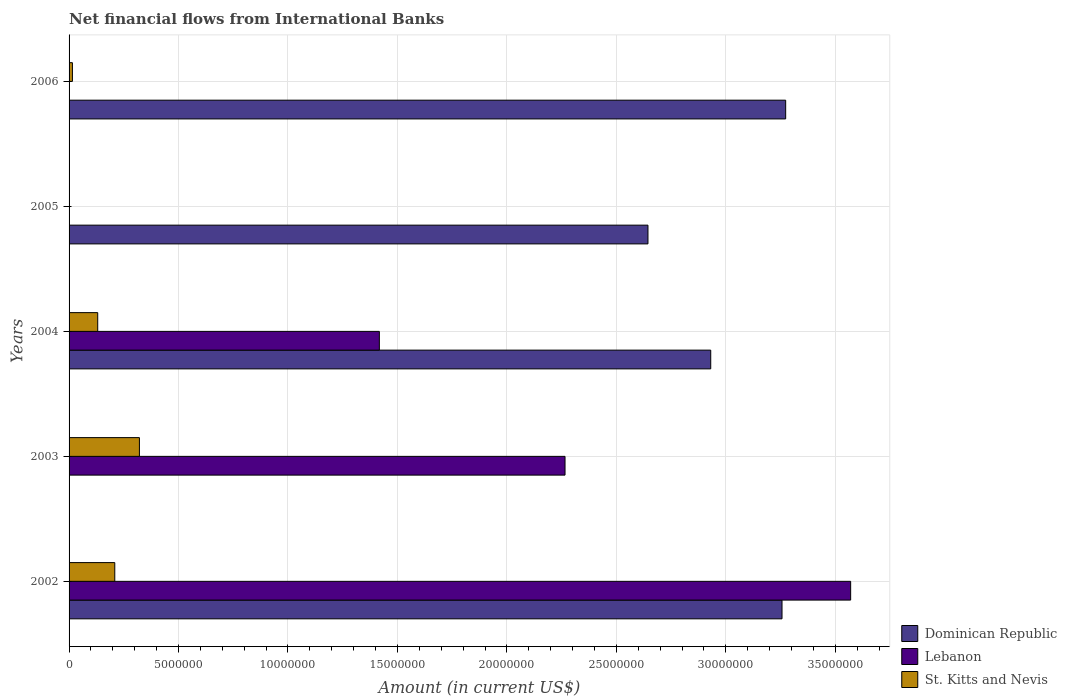How many different coloured bars are there?
Your response must be concise. 3. Are the number of bars per tick equal to the number of legend labels?
Your response must be concise. No. How many bars are there on the 2nd tick from the bottom?
Offer a terse response. 2. What is the label of the 4th group of bars from the top?
Keep it short and to the point. 2003. In how many cases, is the number of bars for a given year not equal to the number of legend labels?
Ensure brevity in your answer.  3. What is the net financial aid flows in Lebanon in 2004?
Offer a terse response. 1.42e+07. Across all years, what is the maximum net financial aid flows in Lebanon?
Provide a succinct answer. 3.57e+07. Across all years, what is the minimum net financial aid flows in Lebanon?
Make the answer very short. 0. In which year was the net financial aid flows in Lebanon maximum?
Offer a very short reply. 2002. What is the total net financial aid flows in Lebanon in the graph?
Give a very brief answer. 7.25e+07. What is the difference between the net financial aid flows in Dominican Republic in 2002 and that in 2006?
Provide a succinct answer. -1.67e+05. What is the difference between the net financial aid flows in Dominican Republic in 2006 and the net financial aid flows in St. Kitts and Nevis in 2003?
Offer a very short reply. 2.95e+07. What is the average net financial aid flows in Dominican Republic per year?
Your response must be concise. 2.42e+07. In the year 2002, what is the difference between the net financial aid flows in Dominican Republic and net financial aid flows in Lebanon?
Make the answer very short. -3.14e+06. What is the ratio of the net financial aid flows in St. Kitts and Nevis in 2003 to that in 2006?
Keep it short and to the point. 21.01. Is the net financial aid flows in Dominican Republic in 2002 less than that in 2005?
Give a very brief answer. No. What is the difference between the highest and the second highest net financial aid flows in Lebanon?
Provide a succinct answer. 1.30e+07. What is the difference between the highest and the lowest net financial aid flows in Dominican Republic?
Ensure brevity in your answer.  3.27e+07. In how many years, is the net financial aid flows in Lebanon greater than the average net financial aid flows in Lebanon taken over all years?
Your response must be concise. 2. Is it the case that in every year, the sum of the net financial aid flows in Dominican Republic and net financial aid flows in St. Kitts and Nevis is greater than the net financial aid flows in Lebanon?
Ensure brevity in your answer.  No. How many bars are there?
Your answer should be compact. 11. Are all the bars in the graph horizontal?
Provide a short and direct response. Yes. What is the difference between two consecutive major ticks on the X-axis?
Provide a succinct answer. 5.00e+06. Does the graph contain any zero values?
Keep it short and to the point. Yes. Does the graph contain grids?
Your answer should be compact. Yes. Where does the legend appear in the graph?
Your answer should be very brief. Bottom right. How many legend labels are there?
Make the answer very short. 3. How are the legend labels stacked?
Your response must be concise. Vertical. What is the title of the graph?
Keep it short and to the point. Net financial flows from International Banks. What is the label or title of the X-axis?
Make the answer very short. Amount (in current US$). What is the Amount (in current US$) in Dominican Republic in 2002?
Offer a terse response. 3.26e+07. What is the Amount (in current US$) in Lebanon in 2002?
Ensure brevity in your answer.  3.57e+07. What is the Amount (in current US$) in St. Kitts and Nevis in 2002?
Make the answer very short. 2.09e+06. What is the Amount (in current US$) of Lebanon in 2003?
Give a very brief answer. 2.27e+07. What is the Amount (in current US$) of St. Kitts and Nevis in 2003?
Ensure brevity in your answer.  3.21e+06. What is the Amount (in current US$) in Dominican Republic in 2004?
Offer a terse response. 2.93e+07. What is the Amount (in current US$) in Lebanon in 2004?
Offer a very short reply. 1.42e+07. What is the Amount (in current US$) of St. Kitts and Nevis in 2004?
Make the answer very short. 1.31e+06. What is the Amount (in current US$) of Dominican Republic in 2005?
Your response must be concise. 2.64e+07. What is the Amount (in current US$) of St. Kitts and Nevis in 2005?
Give a very brief answer. 0. What is the Amount (in current US$) of Dominican Republic in 2006?
Your answer should be very brief. 3.27e+07. What is the Amount (in current US$) in St. Kitts and Nevis in 2006?
Make the answer very short. 1.53e+05. Across all years, what is the maximum Amount (in current US$) of Dominican Republic?
Provide a succinct answer. 3.27e+07. Across all years, what is the maximum Amount (in current US$) in Lebanon?
Your answer should be very brief. 3.57e+07. Across all years, what is the maximum Amount (in current US$) of St. Kitts and Nevis?
Provide a succinct answer. 3.21e+06. Across all years, what is the minimum Amount (in current US$) of Dominican Republic?
Your answer should be compact. 0. Across all years, what is the minimum Amount (in current US$) of Lebanon?
Offer a terse response. 0. What is the total Amount (in current US$) in Dominican Republic in the graph?
Give a very brief answer. 1.21e+08. What is the total Amount (in current US$) of Lebanon in the graph?
Your answer should be very brief. 7.25e+07. What is the total Amount (in current US$) in St. Kitts and Nevis in the graph?
Keep it short and to the point. 6.76e+06. What is the difference between the Amount (in current US$) in Lebanon in 2002 and that in 2003?
Offer a very short reply. 1.30e+07. What is the difference between the Amount (in current US$) of St. Kitts and Nevis in 2002 and that in 2003?
Keep it short and to the point. -1.13e+06. What is the difference between the Amount (in current US$) of Dominican Republic in 2002 and that in 2004?
Your answer should be very brief. 3.26e+06. What is the difference between the Amount (in current US$) in Lebanon in 2002 and that in 2004?
Give a very brief answer. 2.15e+07. What is the difference between the Amount (in current US$) of St. Kitts and Nevis in 2002 and that in 2004?
Keep it short and to the point. 7.79e+05. What is the difference between the Amount (in current US$) in Dominican Republic in 2002 and that in 2005?
Provide a succinct answer. 6.12e+06. What is the difference between the Amount (in current US$) of Dominican Republic in 2002 and that in 2006?
Give a very brief answer. -1.67e+05. What is the difference between the Amount (in current US$) in St. Kitts and Nevis in 2002 and that in 2006?
Provide a succinct answer. 1.94e+06. What is the difference between the Amount (in current US$) in Lebanon in 2003 and that in 2004?
Provide a short and direct response. 8.48e+06. What is the difference between the Amount (in current US$) of St. Kitts and Nevis in 2003 and that in 2004?
Provide a short and direct response. 1.90e+06. What is the difference between the Amount (in current US$) in St. Kitts and Nevis in 2003 and that in 2006?
Offer a terse response. 3.06e+06. What is the difference between the Amount (in current US$) of Dominican Republic in 2004 and that in 2005?
Ensure brevity in your answer.  2.87e+06. What is the difference between the Amount (in current US$) of Dominican Republic in 2004 and that in 2006?
Make the answer very short. -3.42e+06. What is the difference between the Amount (in current US$) in St. Kitts and Nevis in 2004 and that in 2006?
Keep it short and to the point. 1.16e+06. What is the difference between the Amount (in current US$) in Dominican Republic in 2005 and that in 2006?
Your answer should be very brief. -6.29e+06. What is the difference between the Amount (in current US$) of Dominican Republic in 2002 and the Amount (in current US$) of Lebanon in 2003?
Provide a succinct answer. 9.91e+06. What is the difference between the Amount (in current US$) of Dominican Republic in 2002 and the Amount (in current US$) of St. Kitts and Nevis in 2003?
Give a very brief answer. 2.94e+07. What is the difference between the Amount (in current US$) of Lebanon in 2002 and the Amount (in current US$) of St. Kitts and Nevis in 2003?
Ensure brevity in your answer.  3.25e+07. What is the difference between the Amount (in current US$) of Dominican Republic in 2002 and the Amount (in current US$) of Lebanon in 2004?
Keep it short and to the point. 1.84e+07. What is the difference between the Amount (in current US$) in Dominican Republic in 2002 and the Amount (in current US$) in St. Kitts and Nevis in 2004?
Give a very brief answer. 3.13e+07. What is the difference between the Amount (in current US$) in Lebanon in 2002 and the Amount (in current US$) in St. Kitts and Nevis in 2004?
Give a very brief answer. 3.44e+07. What is the difference between the Amount (in current US$) of Dominican Republic in 2002 and the Amount (in current US$) of St. Kitts and Nevis in 2006?
Make the answer very short. 3.24e+07. What is the difference between the Amount (in current US$) in Lebanon in 2002 and the Amount (in current US$) in St. Kitts and Nevis in 2006?
Provide a succinct answer. 3.56e+07. What is the difference between the Amount (in current US$) in Lebanon in 2003 and the Amount (in current US$) in St. Kitts and Nevis in 2004?
Ensure brevity in your answer.  2.13e+07. What is the difference between the Amount (in current US$) in Lebanon in 2003 and the Amount (in current US$) in St. Kitts and Nevis in 2006?
Offer a very short reply. 2.25e+07. What is the difference between the Amount (in current US$) in Dominican Republic in 2004 and the Amount (in current US$) in St. Kitts and Nevis in 2006?
Give a very brief answer. 2.92e+07. What is the difference between the Amount (in current US$) in Lebanon in 2004 and the Amount (in current US$) in St. Kitts and Nevis in 2006?
Provide a short and direct response. 1.40e+07. What is the difference between the Amount (in current US$) in Dominican Republic in 2005 and the Amount (in current US$) in St. Kitts and Nevis in 2006?
Offer a very short reply. 2.63e+07. What is the average Amount (in current US$) of Dominican Republic per year?
Your response must be concise. 2.42e+07. What is the average Amount (in current US$) in Lebanon per year?
Provide a short and direct response. 1.45e+07. What is the average Amount (in current US$) of St. Kitts and Nevis per year?
Your response must be concise. 1.35e+06. In the year 2002, what is the difference between the Amount (in current US$) in Dominican Republic and Amount (in current US$) in Lebanon?
Make the answer very short. -3.14e+06. In the year 2002, what is the difference between the Amount (in current US$) of Dominican Republic and Amount (in current US$) of St. Kitts and Nevis?
Ensure brevity in your answer.  3.05e+07. In the year 2002, what is the difference between the Amount (in current US$) of Lebanon and Amount (in current US$) of St. Kitts and Nevis?
Your response must be concise. 3.36e+07. In the year 2003, what is the difference between the Amount (in current US$) in Lebanon and Amount (in current US$) in St. Kitts and Nevis?
Keep it short and to the point. 1.94e+07. In the year 2004, what is the difference between the Amount (in current US$) of Dominican Republic and Amount (in current US$) of Lebanon?
Your response must be concise. 1.51e+07. In the year 2004, what is the difference between the Amount (in current US$) of Dominican Republic and Amount (in current US$) of St. Kitts and Nevis?
Your answer should be very brief. 2.80e+07. In the year 2004, what is the difference between the Amount (in current US$) of Lebanon and Amount (in current US$) of St. Kitts and Nevis?
Provide a succinct answer. 1.29e+07. In the year 2006, what is the difference between the Amount (in current US$) of Dominican Republic and Amount (in current US$) of St. Kitts and Nevis?
Your answer should be compact. 3.26e+07. What is the ratio of the Amount (in current US$) in Lebanon in 2002 to that in 2003?
Offer a very short reply. 1.58. What is the ratio of the Amount (in current US$) in St. Kitts and Nevis in 2002 to that in 2003?
Ensure brevity in your answer.  0.65. What is the ratio of the Amount (in current US$) of Lebanon in 2002 to that in 2004?
Keep it short and to the point. 2.52. What is the ratio of the Amount (in current US$) of St. Kitts and Nevis in 2002 to that in 2004?
Make the answer very short. 1.6. What is the ratio of the Amount (in current US$) of Dominican Republic in 2002 to that in 2005?
Your answer should be very brief. 1.23. What is the ratio of the Amount (in current US$) of St. Kitts and Nevis in 2002 to that in 2006?
Provide a short and direct response. 13.65. What is the ratio of the Amount (in current US$) of Lebanon in 2003 to that in 2004?
Give a very brief answer. 1.6. What is the ratio of the Amount (in current US$) in St. Kitts and Nevis in 2003 to that in 2004?
Make the answer very short. 2.46. What is the ratio of the Amount (in current US$) in St. Kitts and Nevis in 2003 to that in 2006?
Offer a very short reply. 21.01. What is the ratio of the Amount (in current US$) in Dominican Republic in 2004 to that in 2005?
Offer a very short reply. 1.11. What is the ratio of the Amount (in current US$) in Dominican Republic in 2004 to that in 2006?
Your answer should be compact. 0.9. What is the ratio of the Amount (in current US$) in St. Kitts and Nevis in 2004 to that in 2006?
Ensure brevity in your answer.  8.56. What is the ratio of the Amount (in current US$) in Dominican Republic in 2005 to that in 2006?
Your answer should be very brief. 0.81. What is the difference between the highest and the second highest Amount (in current US$) in Dominican Republic?
Ensure brevity in your answer.  1.67e+05. What is the difference between the highest and the second highest Amount (in current US$) in Lebanon?
Give a very brief answer. 1.30e+07. What is the difference between the highest and the second highest Amount (in current US$) of St. Kitts and Nevis?
Provide a short and direct response. 1.13e+06. What is the difference between the highest and the lowest Amount (in current US$) in Dominican Republic?
Keep it short and to the point. 3.27e+07. What is the difference between the highest and the lowest Amount (in current US$) in Lebanon?
Your answer should be very brief. 3.57e+07. What is the difference between the highest and the lowest Amount (in current US$) of St. Kitts and Nevis?
Your answer should be very brief. 3.21e+06. 